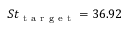Convert formula to latex. <formula><loc_0><loc_0><loc_500><loc_500>S t _ { t a r g e t } = 3 6 . 9 2</formula> 